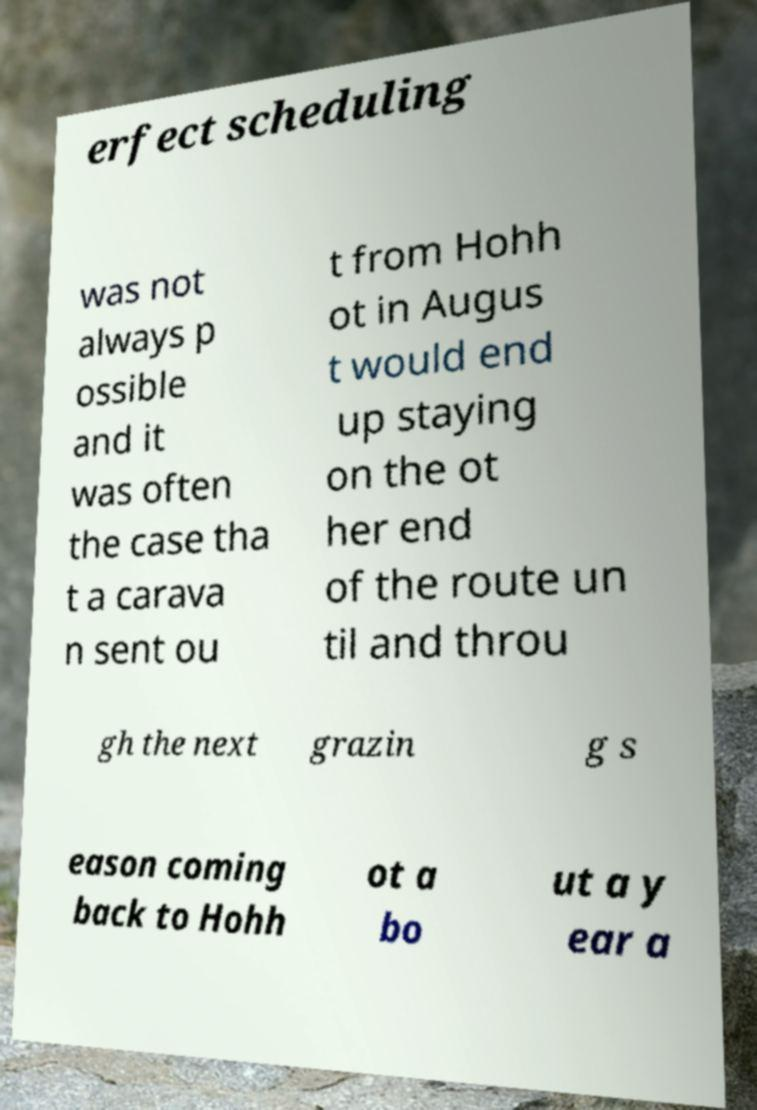Can you accurately transcribe the text from the provided image for me? erfect scheduling was not always p ossible and it was often the case tha t a carava n sent ou t from Hohh ot in Augus t would end up staying on the ot her end of the route un til and throu gh the next grazin g s eason coming back to Hohh ot a bo ut a y ear a 